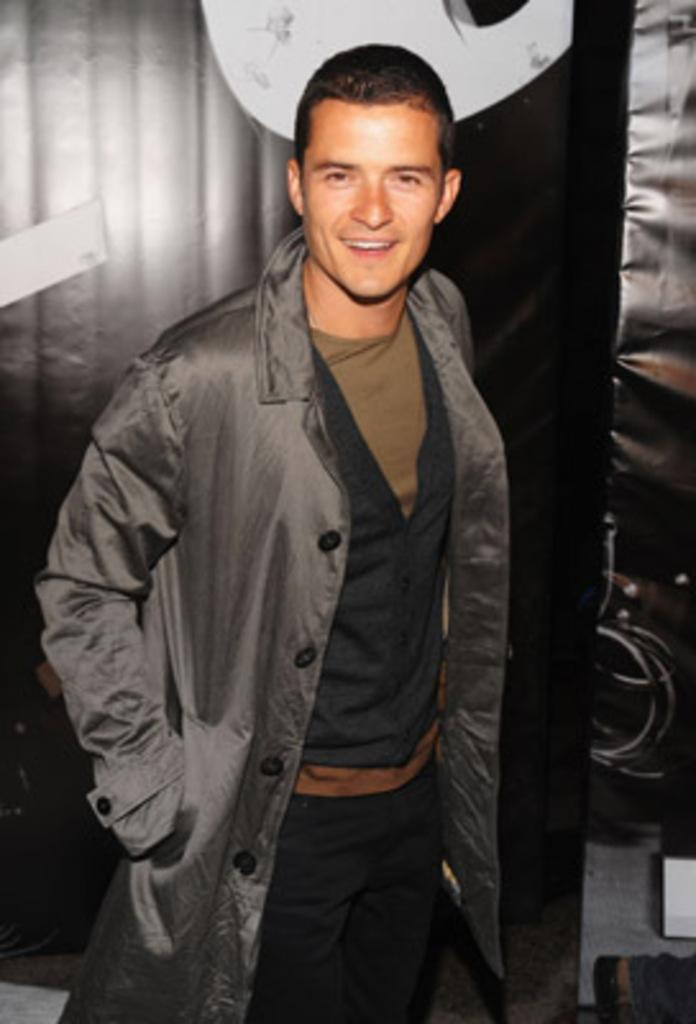What is the main subject of the image? There is a person standing in the image. Can you describe the person's clothing? The person is wearing a grey coat. What is the person's facial expression? The person is smiling. What can be seen in the background of the image? There is a curtain in the background of the image. What colors are present on the curtain? The curtain has grey and black colors. How many captions are present in the image? There are no captions present in the image. What type of lace can be seen on the person's clothing? There is no lace visible on the person's clothing, as they are wearing a grey coat. 